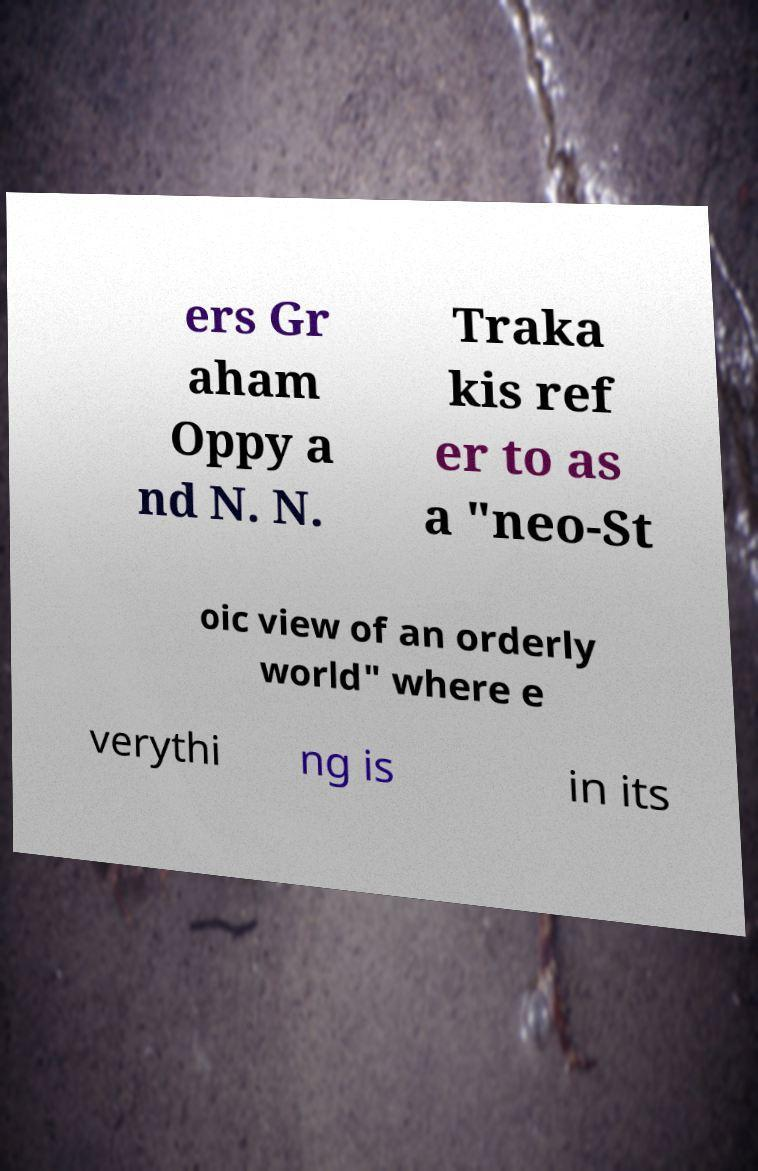Can you read and provide the text displayed in the image?This photo seems to have some interesting text. Can you extract and type it out for me? ers Gr aham Oppy a nd N. N. Traka kis ref er to as a "neo-St oic view of an orderly world" where e verythi ng is in its 